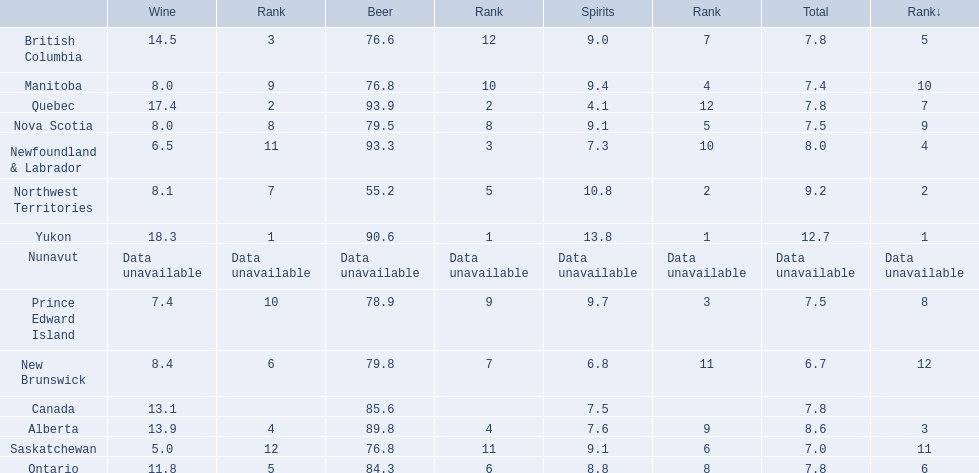What is the first ranked alcoholic beverage in canada Yukon. How many litters is consumed a year? 12.7. 